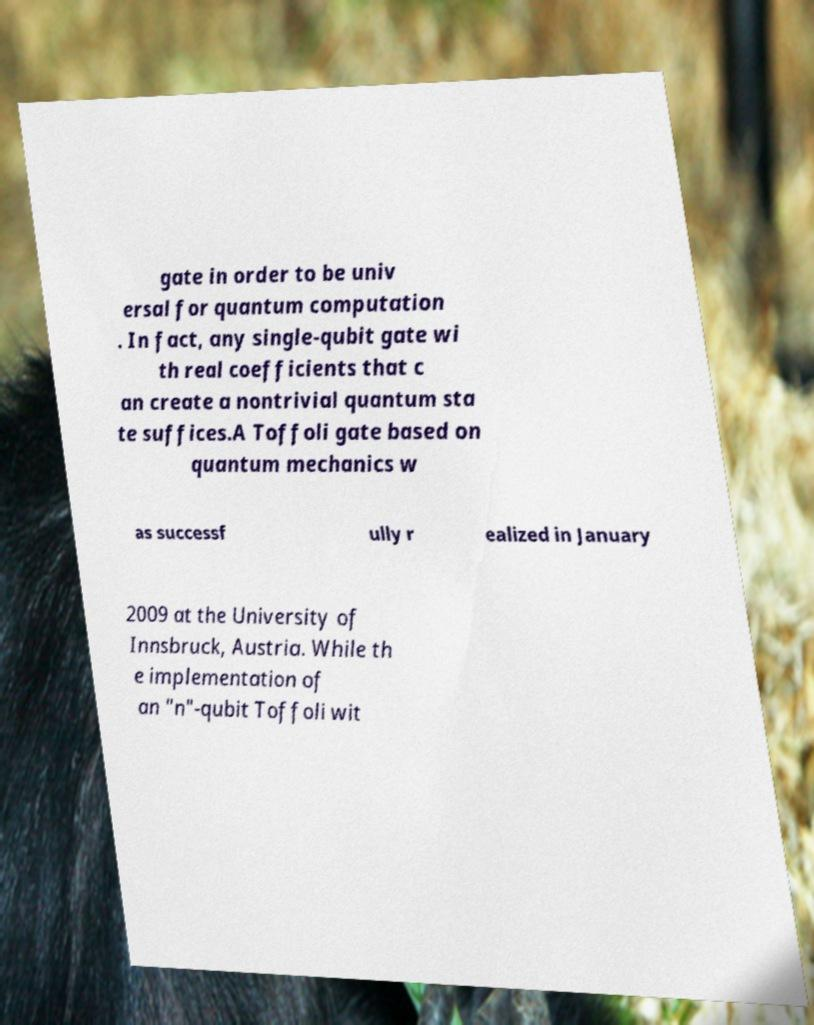Can you accurately transcribe the text from the provided image for me? gate in order to be univ ersal for quantum computation . In fact, any single-qubit gate wi th real coefficients that c an create a nontrivial quantum sta te suffices.A Toffoli gate based on quantum mechanics w as successf ully r ealized in January 2009 at the University of Innsbruck, Austria. While th e implementation of an "n"-qubit Toffoli wit 